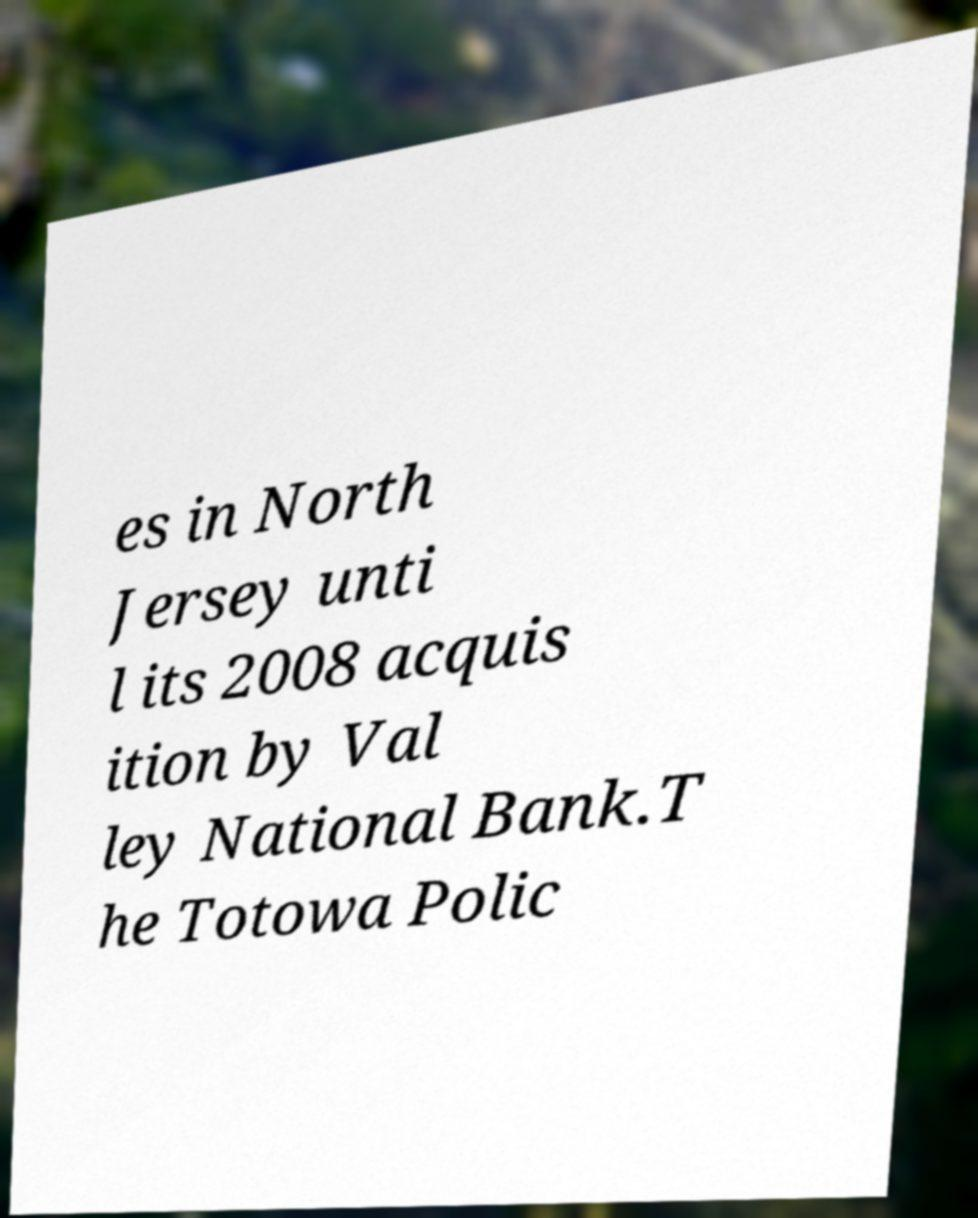What messages or text are displayed in this image? I need them in a readable, typed format. es in North Jersey unti l its 2008 acquis ition by Val ley National Bank.T he Totowa Polic 